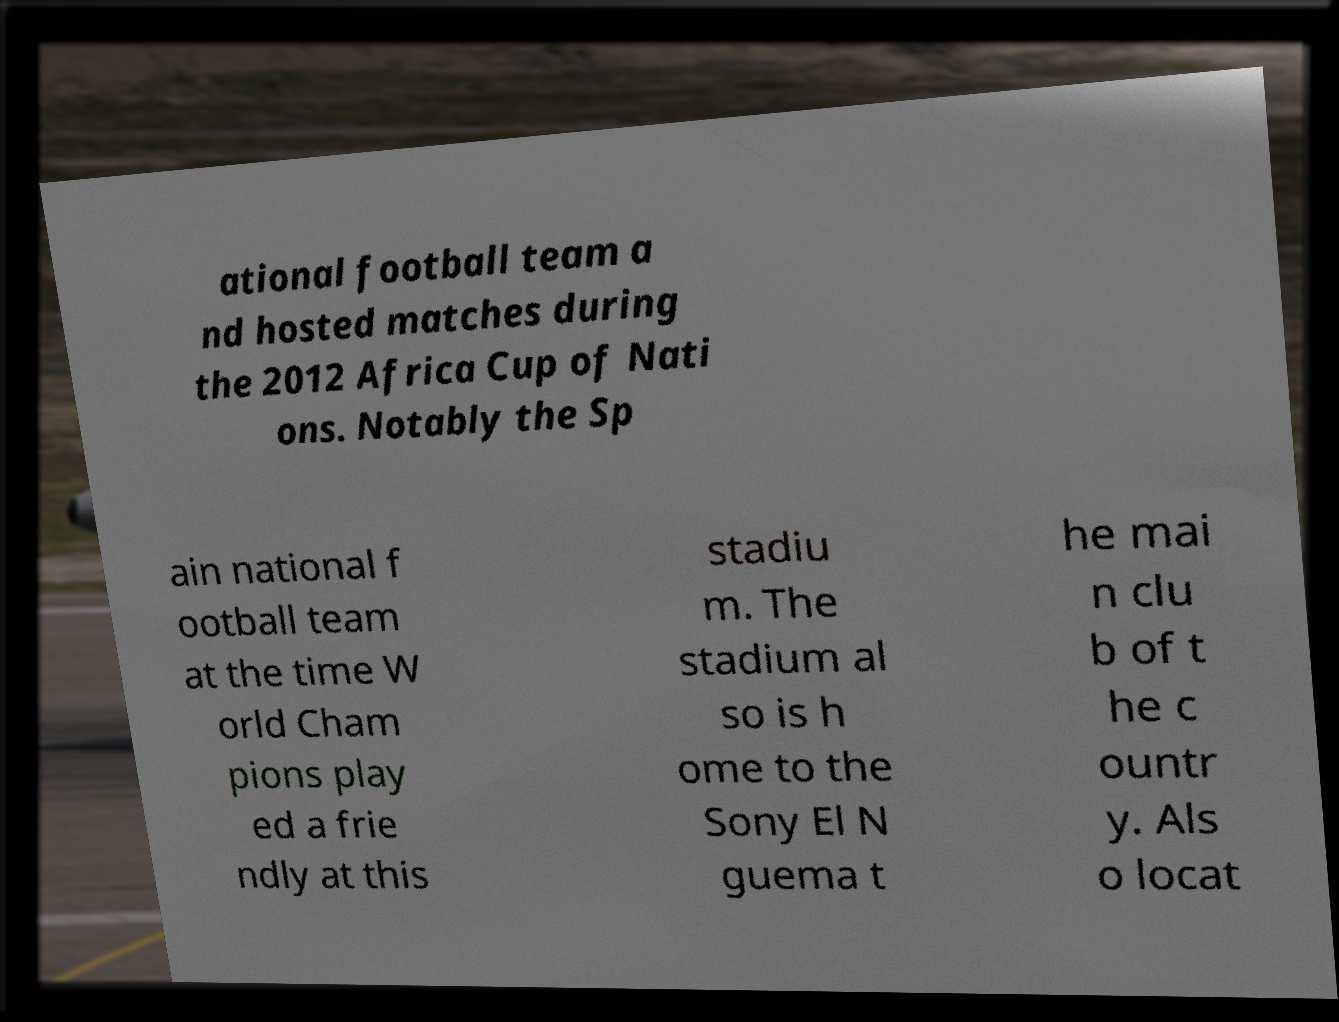Could you extract and type out the text from this image? ational football team a nd hosted matches during the 2012 Africa Cup of Nati ons. Notably the Sp ain national f ootball team at the time W orld Cham pions play ed a frie ndly at this stadiu m. The stadium al so is h ome to the Sony El N guema t he mai n clu b of t he c ountr y. Als o locat 